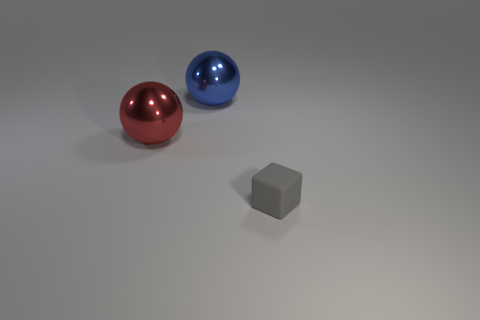If this scene were part of a physics experiment, what could be the possible hypothesis or objective? If this scene represented a physics experiment, the objective could be to study properties like reflection, refraction, and shadow casting in relation to material and color characteristics, or even to observe the effects of surface texture and ambient light on the appearance of objects in a controlled environment. 